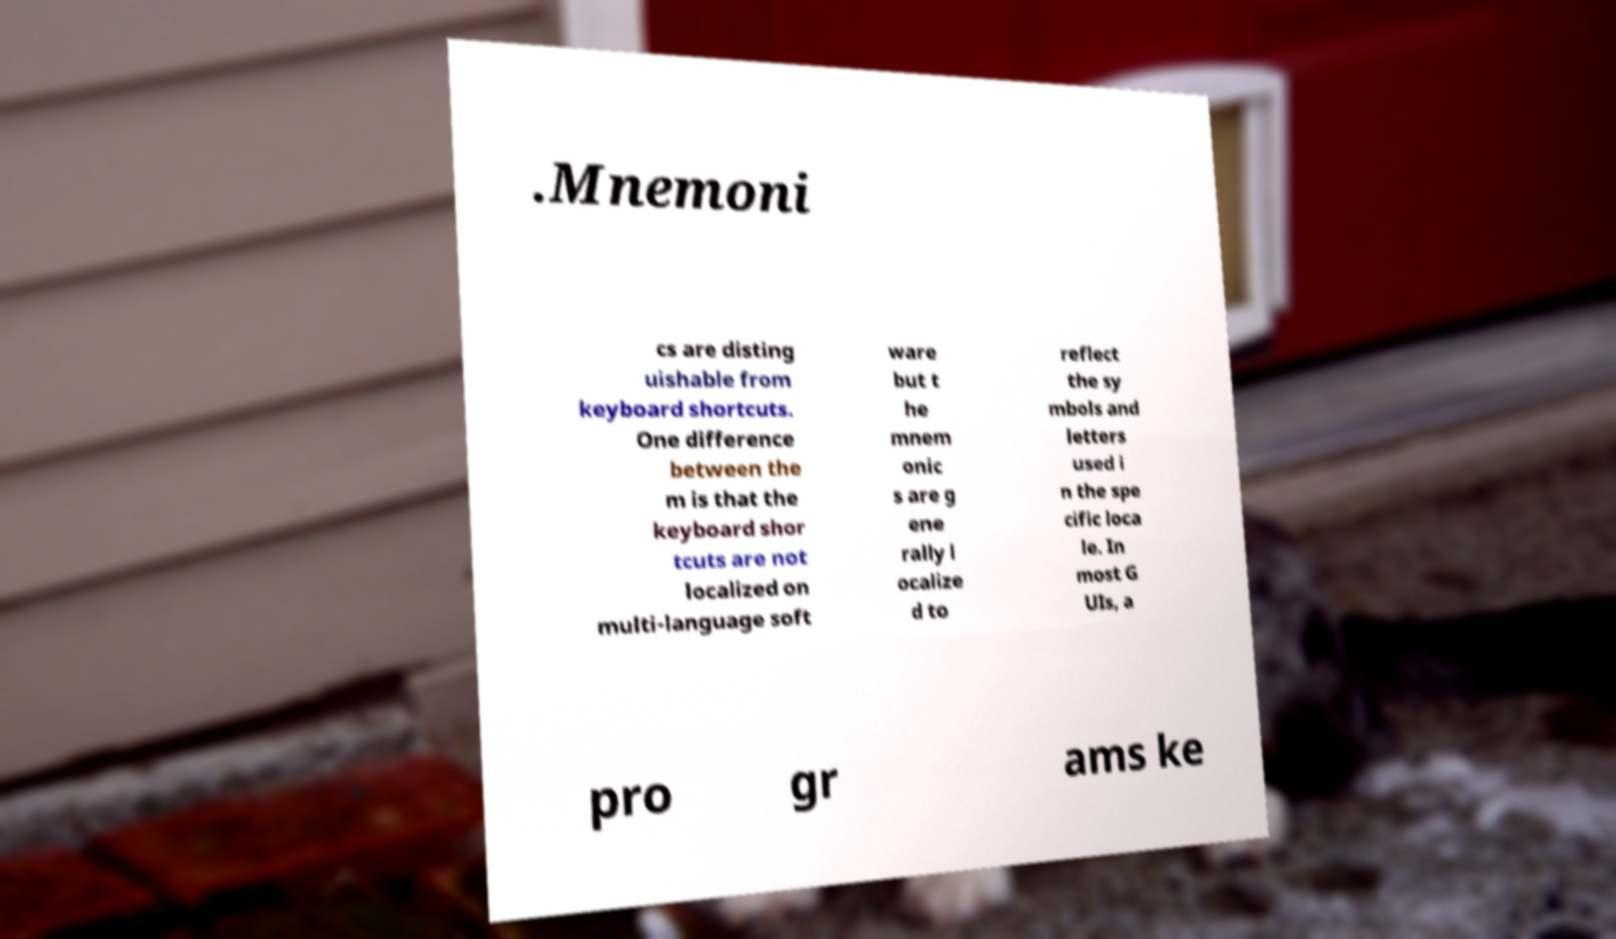Can you read and provide the text displayed in the image?This photo seems to have some interesting text. Can you extract and type it out for me? .Mnemoni cs are disting uishable from keyboard shortcuts. One difference between the m is that the keyboard shor tcuts are not localized on multi-language soft ware but t he mnem onic s are g ene rally l ocalize d to reflect the sy mbols and letters used i n the spe cific loca le. In most G UIs, a pro gr ams ke 